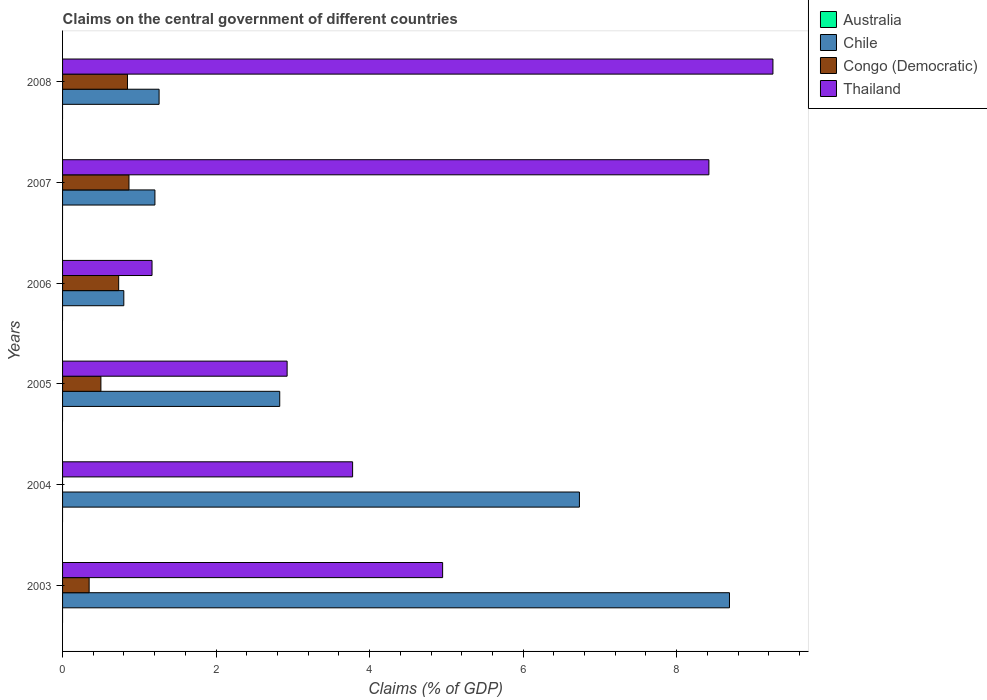How many different coloured bars are there?
Keep it short and to the point. 3. How many groups of bars are there?
Your answer should be compact. 6. Are the number of bars on each tick of the Y-axis equal?
Your answer should be compact. No. How many bars are there on the 2nd tick from the bottom?
Give a very brief answer. 2. What is the percentage of GDP claimed on the central government in Congo (Democratic) in 2005?
Ensure brevity in your answer.  0.5. Across all years, what is the maximum percentage of GDP claimed on the central government in Thailand?
Make the answer very short. 9.25. Across all years, what is the minimum percentage of GDP claimed on the central government in Australia?
Ensure brevity in your answer.  0. What is the total percentage of GDP claimed on the central government in Congo (Democratic) in the graph?
Your answer should be very brief. 3.29. What is the difference between the percentage of GDP claimed on the central government in Chile in 2006 and that in 2007?
Give a very brief answer. -0.41. What is the difference between the percentage of GDP claimed on the central government in Thailand in 2004 and the percentage of GDP claimed on the central government in Congo (Democratic) in 2007?
Your response must be concise. 2.91. What is the average percentage of GDP claimed on the central government in Congo (Democratic) per year?
Your answer should be compact. 0.55. In the year 2005, what is the difference between the percentage of GDP claimed on the central government in Chile and percentage of GDP claimed on the central government in Congo (Democratic)?
Make the answer very short. 2.33. In how many years, is the percentage of GDP claimed on the central government in Australia greater than 8 %?
Offer a very short reply. 0. What is the ratio of the percentage of GDP claimed on the central government in Thailand in 2004 to that in 2007?
Your answer should be compact. 0.45. Is the percentage of GDP claimed on the central government in Chile in 2006 less than that in 2008?
Your answer should be compact. Yes. Is the difference between the percentage of GDP claimed on the central government in Chile in 2005 and 2008 greater than the difference between the percentage of GDP claimed on the central government in Congo (Democratic) in 2005 and 2008?
Your answer should be compact. Yes. What is the difference between the highest and the second highest percentage of GDP claimed on the central government in Thailand?
Your answer should be very brief. 0.83. What is the difference between the highest and the lowest percentage of GDP claimed on the central government in Chile?
Offer a terse response. 7.89. In how many years, is the percentage of GDP claimed on the central government in Thailand greater than the average percentage of GDP claimed on the central government in Thailand taken over all years?
Provide a short and direct response. 2. Is the sum of the percentage of GDP claimed on the central government in Chile in 2005 and 2007 greater than the maximum percentage of GDP claimed on the central government in Congo (Democratic) across all years?
Keep it short and to the point. Yes. Are all the bars in the graph horizontal?
Make the answer very short. Yes. How many years are there in the graph?
Give a very brief answer. 6. What is the difference between two consecutive major ticks on the X-axis?
Provide a succinct answer. 2. Are the values on the major ticks of X-axis written in scientific E-notation?
Provide a short and direct response. No. Does the graph contain grids?
Offer a very short reply. No. Where does the legend appear in the graph?
Your answer should be very brief. Top right. What is the title of the graph?
Provide a short and direct response. Claims on the central government of different countries. Does "Turkey" appear as one of the legend labels in the graph?
Your response must be concise. No. What is the label or title of the X-axis?
Your answer should be very brief. Claims (% of GDP). What is the Claims (% of GDP) of Chile in 2003?
Your answer should be compact. 8.69. What is the Claims (% of GDP) of Congo (Democratic) in 2003?
Provide a succinct answer. 0.35. What is the Claims (% of GDP) in Thailand in 2003?
Give a very brief answer. 4.95. What is the Claims (% of GDP) of Australia in 2004?
Your answer should be compact. 0. What is the Claims (% of GDP) in Chile in 2004?
Offer a very short reply. 6.73. What is the Claims (% of GDP) of Thailand in 2004?
Your response must be concise. 3.78. What is the Claims (% of GDP) of Australia in 2005?
Provide a succinct answer. 0. What is the Claims (% of GDP) in Chile in 2005?
Make the answer very short. 2.83. What is the Claims (% of GDP) in Congo (Democratic) in 2005?
Provide a succinct answer. 0.5. What is the Claims (% of GDP) of Thailand in 2005?
Your response must be concise. 2.93. What is the Claims (% of GDP) of Chile in 2006?
Offer a terse response. 0.8. What is the Claims (% of GDP) in Congo (Democratic) in 2006?
Your answer should be compact. 0.73. What is the Claims (% of GDP) in Thailand in 2006?
Your answer should be compact. 1.17. What is the Claims (% of GDP) in Australia in 2007?
Provide a short and direct response. 0. What is the Claims (% of GDP) of Chile in 2007?
Ensure brevity in your answer.  1.2. What is the Claims (% of GDP) in Congo (Democratic) in 2007?
Make the answer very short. 0.87. What is the Claims (% of GDP) of Thailand in 2007?
Give a very brief answer. 8.42. What is the Claims (% of GDP) of Australia in 2008?
Your answer should be very brief. 0. What is the Claims (% of GDP) of Chile in 2008?
Your answer should be very brief. 1.26. What is the Claims (% of GDP) in Congo (Democratic) in 2008?
Ensure brevity in your answer.  0.85. What is the Claims (% of GDP) of Thailand in 2008?
Keep it short and to the point. 9.25. Across all years, what is the maximum Claims (% of GDP) of Chile?
Provide a succinct answer. 8.69. Across all years, what is the maximum Claims (% of GDP) in Congo (Democratic)?
Give a very brief answer. 0.87. Across all years, what is the maximum Claims (% of GDP) in Thailand?
Ensure brevity in your answer.  9.25. Across all years, what is the minimum Claims (% of GDP) in Chile?
Give a very brief answer. 0.8. Across all years, what is the minimum Claims (% of GDP) of Congo (Democratic)?
Offer a terse response. 0. Across all years, what is the minimum Claims (% of GDP) of Thailand?
Provide a short and direct response. 1.17. What is the total Claims (% of GDP) in Australia in the graph?
Ensure brevity in your answer.  0. What is the total Claims (% of GDP) in Chile in the graph?
Your response must be concise. 21.51. What is the total Claims (% of GDP) of Congo (Democratic) in the graph?
Keep it short and to the point. 3.29. What is the total Claims (% of GDP) of Thailand in the graph?
Provide a succinct answer. 30.49. What is the difference between the Claims (% of GDP) of Chile in 2003 and that in 2004?
Ensure brevity in your answer.  1.95. What is the difference between the Claims (% of GDP) of Thailand in 2003 and that in 2004?
Provide a short and direct response. 1.17. What is the difference between the Claims (% of GDP) in Chile in 2003 and that in 2005?
Your response must be concise. 5.86. What is the difference between the Claims (% of GDP) in Congo (Democratic) in 2003 and that in 2005?
Keep it short and to the point. -0.15. What is the difference between the Claims (% of GDP) in Thailand in 2003 and that in 2005?
Offer a very short reply. 2.03. What is the difference between the Claims (% of GDP) in Chile in 2003 and that in 2006?
Offer a terse response. 7.89. What is the difference between the Claims (% of GDP) in Congo (Democratic) in 2003 and that in 2006?
Ensure brevity in your answer.  -0.38. What is the difference between the Claims (% of GDP) in Thailand in 2003 and that in 2006?
Your answer should be very brief. 3.79. What is the difference between the Claims (% of GDP) of Chile in 2003 and that in 2007?
Provide a succinct answer. 7.48. What is the difference between the Claims (% of GDP) of Congo (Democratic) in 2003 and that in 2007?
Provide a succinct answer. -0.52. What is the difference between the Claims (% of GDP) in Thailand in 2003 and that in 2007?
Provide a succinct answer. -3.47. What is the difference between the Claims (% of GDP) of Chile in 2003 and that in 2008?
Offer a very short reply. 7.43. What is the difference between the Claims (% of GDP) of Congo (Democratic) in 2003 and that in 2008?
Make the answer very short. -0.5. What is the difference between the Claims (% of GDP) in Thailand in 2003 and that in 2008?
Your answer should be very brief. -4.3. What is the difference between the Claims (% of GDP) in Chile in 2004 and that in 2005?
Your answer should be very brief. 3.9. What is the difference between the Claims (% of GDP) of Thailand in 2004 and that in 2005?
Your answer should be very brief. 0.85. What is the difference between the Claims (% of GDP) of Chile in 2004 and that in 2006?
Your answer should be very brief. 5.94. What is the difference between the Claims (% of GDP) in Thailand in 2004 and that in 2006?
Offer a terse response. 2.61. What is the difference between the Claims (% of GDP) of Chile in 2004 and that in 2007?
Offer a terse response. 5.53. What is the difference between the Claims (% of GDP) of Thailand in 2004 and that in 2007?
Keep it short and to the point. -4.64. What is the difference between the Claims (% of GDP) of Chile in 2004 and that in 2008?
Offer a terse response. 5.48. What is the difference between the Claims (% of GDP) of Thailand in 2004 and that in 2008?
Provide a succinct answer. -5.48. What is the difference between the Claims (% of GDP) in Chile in 2005 and that in 2006?
Your answer should be compact. 2.03. What is the difference between the Claims (% of GDP) of Congo (Democratic) in 2005 and that in 2006?
Provide a succinct answer. -0.23. What is the difference between the Claims (% of GDP) of Thailand in 2005 and that in 2006?
Your answer should be compact. 1.76. What is the difference between the Claims (% of GDP) of Chile in 2005 and that in 2007?
Give a very brief answer. 1.63. What is the difference between the Claims (% of GDP) in Congo (Democratic) in 2005 and that in 2007?
Your response must be concise. -0.37. What is the difference between the Claims (% of GDP) in Thailand in 2005 and that in 2007?
Your answer should be compact. -5.49. What is the difference between the Claims (% of GDP) of Chile in 2005 and that in 2008?
Offer a very short reply. 1.57. What is the difference between the Claims (% of GDP) of Congo (Democratic) in 2005 and that in 2008?
Your response must be concise. -0.35. What is the difference between the Claims (% of GDP) of Thailand in 2005 and that in 2008?
Offer a terse response. -6.33. What is the difference between the Claims (% of GDP) of Chile in 2006 and that in 2007?
Offer a very short reply. -0.41. What is the difference between the Claims (% of GDP) in Congo (Democratic) in 2006 and that in 2007?
Offer a very short reply. -0.13. What is the difference between the Claims (% of GDP) of Thailand in 2006 and that in 2007?
Make the answer very short. -7.25. What is the difference between the Claims (% of GDP) of Chile in 2006 and that in 2008?
Give a very brief answer. -0.46. What is the difference between the Claims (% of GDP) in Congo (Democratic) in 2006 and that in 2008?
Offer a very short reply. -0.11. What is the difference between the Claims (% of GDP) in Thailand in 2006 and that in 2008?
Your answer should be compact. -8.09. What is the difference between the Claims (% of GDP) of Chile in 2007 and that in 2008?
Keep it short and to the point. -0.05. What is the difference between the Claims (% of GDP) of Congo (Democratic) in 2007 and that in 2008?
Provide a short and direct response. 0.02. What is the difference between the Claims (% of GDP) in Thailand in 2007 and that in 2008?
Offer a very short reply. -0.83. What is the difference between the Claims (% of GDP) in Chile in 2003 and the Claims (% of GDP) in Thailand in 2004?
Your answer should be very brief. 4.91. What is the difference between the Claims (% of GDP) of Congo (Democratic) in 2003 and the Claims (% of GDP) of Thailand in 2004?
Provide a short and direct response. -3.43. What is the difference between the Claims (% of GDP) in Chile in 2003 and the Claims (% of GDP) in Congo (Democratic) in 2005?
Keep it short and to the point. 8.19. What is the difference between the Claims (% of GDP) in Chile in 2003 and the Claims (% of GDP) in Thailand in 2005?
Offer a very short reply. 5.76. What is the difference between the Claims (% of GDP) of Congo (Democratic) in 2003 and the Claims (% of GDP) of Thailand in 2005?
Your answer should be very brief. -2.58. What is the difference between the Claims (% of GDP) in Chile in 2003 and the Claims (% of GDP) in Congo (Democratic) in 2006?
Provide a short and direct response. 7.96. What is the difference between the Claims (% of GDP) in Chile in 2003 and the Claims (% of GDP) in Thailand in 2006?
Ensure brevity in your answer.  7.52. What is the difference between the Claims (% of GDP) of Congo (Democratic) in 2003 and the Claims (% of GDP) of Thailand in 2006?
Offer a very short reply. -0.82. What is the difference between the Claims (% of GDP) in Chile in 2003 and the Claims (% of GDP) in Congo (Democratic) in 2007?
Provide a short and direct response. 7.82. What is the difference between the Claims (% of GDP) in Chile in 2003 and the Claims (% of GDP) in Thailand in 2007?
Offer a very short reply. 0.27. What is the difference between the Claims (% of GDP) in Congo (Democratic) in 2003 and the Claims (% of GDP) in Thailand in 2007?
Make the answer very short. -8.07. What is the difference between the Claims (% of GDP) of Chile in 2003 and the Claims (% of GDP) of Congo (Democratic) in 2008?
Your answer should be very brief. 7.84. What is the difference between the Claims (% of GDP) of Chile in 2003 and the Claims (% of GDP) of Thailand in 2008?
Your answer should be very brief. -0.57. What is the difference between the Claims (% of GDP) of Congo (Democratic) in 2003 and the Claims (% of GDP) of Thailand in 2008?
Ensure brevity in your answer.  -8.91. What is the difference between the Claims (% of GDP) of Chile in 2004 and the Claims (% of GDP) of Congo (Democratic) in 2005?
Offer a terse response. 6.23. What is the difference between the Claims (% of GDP) of Chile in 2004 and the Claims (% of GDP) of Thailand in 2005?
Give a very brief answer. 3.81. What is the difference between the Claims (% of GDP) in Chile in 2004 and the Claims (% of GDP) in Congo (Democratic) in 2006?
Give a very brief answer. 6. What is the difference between the Claims (% of GDP) in Chile in 2004 and the Claims (% of GDP) in Thailand in 2006?
Provide a short and direct response. 5.57. What is the difference between the Claims (% of GDP) in Chile in 2004 and the Claims (% of GDP) in Congo (Democratic) in 2007?
Your response must be concise. 5.87. What is the difference between the Claims (% of GDP) of Chile in 2004 and the Claims (% of GDP) of Thailand in 2007?
Ensure brevity in your answer.  -1.69. What is the difference between the Claims (% of GDP) in Chile in 2004 and the Claims (% of GDP) in Congo (Democratic) in 2008?
Your answer should be compact. 5.89. What is the difference between the Claims (% of GDP) of Chile in 2004 and the Claims (% of GDP) of Thailand in 2008?
Make the answer very short. -2.52. What is the difference between the Claims (% of GDP) in Chile in 2005 and the Claims (% of GDP) in Congo (Democratic) in 2006?
Give a very brief answer. 2.1. What is the difference between the Claims (% of GDP) of Chile in 2005 and the Claims (% of GDP) of Thailand in 2006?
Provide a succinct answer. 1.66. What is the difference between the Claims (% of GDP) in Congo (Democratic) in 2005 and the Claims (% of GDP) in Thailand in 2006?
Offer a terse response. -0.67. What is the difference between the Claims (% of GDP) of Chile in 2005 and the Claims (% of GDP) of Congo (Democratic) in 2007?
Provide a succinct answer. 1.96. What is the difference between the Claims (% of GDP) in Chile in 2005 and the Claims (% of GDP) in Thailand in 2007?
Your answer should be compact. -5.59. What is the difference between the Claims (% of GDP) of Congo (Democratic) in 2005 and the Claims (% of GDP) of Thailand in 2007?
Provide a succinct answer. -7.92. What is the difference between the Claims (% of GDP) of Chile in 2005 and the Claims (% of GDP) of Congo (Democratic) in 2008?
Give a very brief answer. 1.98. What is the difference between the Claims (% of GDP) in Chile in 2005 and the Claims (% of GDP) in Thailand in 2008?
Keep it short and to the point. -6.43. What is the difference between the Claims (% of GDP) of Congo (Democratic) in 2005 and the Claims (% of GDP) of Thailand in 2008?
Make the answer very short. -8.75. What is the difference between the Claims (% of GDP) in Chile in 2006 and the Claims (% of GDP) in Congo (Democratic) in 2007?
Offer a terse response. -0.07. What is the difference between the Claims (% of GDP) in Chile in 2006 and the Claims (% of GDP) in Thailand in 2007?
Make the answer very short. -7.62. What is the difference between the Claims (% of GDP) in Congo (Democratic) in 2006 and the Claims (% of GDP) in Thailand in 2007?
Make the answer very short. -7.69. What is the difference between the Claims (% of GDP) of Chile in 2006 and the Claims (% of GDP) of Congo (Democratic) in 2008?
Ensure brevity in your answer.  -0.05. What is the difference between the Claims (% of GDP) of Chile in 2006 and the Claims (% of GDP) of Thailand in 2008?
Your response must be concise. -8.46. What is the difference between the Claims (% of GDP) in Congo (Democratic) in 2006 and the Claims (% of GDP) in Thailand in 2008?
Offer a terse response. -8.52. What is the difference between the Claims (% of GDP) of Chile in 2007 and the Claims (% of GDP) of Congo (Democratic) in 2008?
Provide a short and direct response. 0.36. What is the difference between the Claims (% of GDP) in Chile in 2007 and the Claims (% of GDP) in Thailand in 2008?
Provide a succinct answer. -8.05. What is the difference between the Claims (% of GDP) of Congo (Democratic) in 2007 and the Claims (% of GDP) of Thailand in 2008?
Your answer should be compact. -8.39. What is the average Claims (% of GDP) of Australia per year?
Provide a succinct answer. 0. What is the average Claims (% of GDP) of Chile per year?
Provide a succinct answer. 3.58. What is the average Claims (% of GDP) of Congo (Democratic) per year?
Make the answer very short. 0.55. What is the average Claims (% of GDP) of Thailand per year?
Offer a terse response. 5.08. In the year 2003, what is the difference between the Claims (% of GDP) in Chile and Claims (% of GDP) in Congo (Democratic)?
Offer a very short reply. 8.34. In the year 2003, what is the difference between the Claims (% of GDP) in Chile and Claims (% of GDP) in Thailand?
Your answer should be very brief. 3.74. In the year 2003, what is the difference between the Claims (% of GDP) of Congo (Democratic) and Claims (% of GDP) of Thailand?
Offer a very short reply. -4.6. In the year 2004, what is the difference between the Claims (% of GDP) in Chile and Claims (% of GDP) in Thailand?
Offer a very short reply. 2.95. In the year 2005, what is the difference between the Claims (% of GDP) in Chile and Claims (% of GDP) in Congo (Democratic)?
Provide a short and direct response. 2.33. In the year 2005, what is the difference between the Claims (% of GDP) of Chile and Claims (% of GDP) of Thailand?
Offer a very short reply. -0.1. In the year 2005, what is the difference between the Claims (% of GDP) of Congo (Democratic) and Claims (% of GDP) of Thailand?
Your answer should be very brief. -2.43. In the year 2006, what is the difference between the Claims (% of GDP) in Chile and Claims (% of GDP) in Congo (Democratic)?
Make the answer very short. 0.07. In the year 2006, what is the difference between the Claims (% of GDP) of Chile and Claims (% of GDP) of Thailand?
Give a very brief answer. -0.37. In the year 2006, what is the difference between the Claims (% of GDP) in Congo (Democratic) and Claims (% of GDP) in Thailand?
Your answer should be very brief. -0.43. In the year 2007, what is the difference between the Claims (% of GDP) in Chile and Claims (% of GDP) in Congo (Democratic)?
Give a very brief answer. 0.34. In the year 2007, what is the difference between the Claims (% of GDP) of Chile and Claims (% of GDP) of Thailand?
Offer a very short reply. -7.22. In the year 2007, what is the difference between the Claims (% of GDP) in Congo (Democratic) and Claims (% of GDP) in Thailand?
Your answer should be compact. -7.55. In the year 2008, what is the difference between the Claims (% of GDP) of Chile and Claims (% of GDP) of Congo (Democratic)?
Your answer should be compact. 0.41. In the year 2008, what is the difference between the Claims (% of GDP) of Chile and Claims (% of GDP) of Thailand?
Your answer should be compact. -8. In the year 2008, what is the difference between the Claims (% of GDP) of Congo (Democratic) and Claims (% of GDP) of Thailand?
Offer a very short reply. -8.41. What is the ratio of the Claims (% of GDP) of Chile in 2003 to that in 2004?
Keep it short and to the point. 1.29. What is the ratio of the Claims (% of GDP) of Thailand in 2003 to that in 2004?
Provide a short and direct response. 1.31. What is the ratio of the Claims (% of GDP) of Chile in 2003 to that in 2005?
Give a very brief answer. 3.07. What is the ratio of the Claims (% of GDP) in Congo (Democratic) in 2003 to that in 2005?
Provide a short and direct response. 0.69. What is the ratio of the Claims (% of GDP) in Thailand in 2003 to that in 2005?
Provide a short and direct response. 1.69. What is the ratio of the Claims (% of GDP) of Chile in 2003 to that in 2006?
Offer a terse response. 10.89. What is the ratio of the Claims (% of GDP) of Congo (Democratic) in 2003 to that in 2006?
Your answer should be compact. 0.47. What is the ratio of the Claims (% of GDP) in Thailand in 2003 to that in 2006?
Provide a short and direct response. 4.25. What is the ratio of the Claims (% of GDP) in Chile in 2003 to that in 2007?
Provide a succinct answer. 7.22. What is the ratio of the Claims (% of GDP) in Congo (Democratic) in 2003 to that in 2007?
Ensure brevity in your answer.  0.4. What is the ratio of the Claims (% of GDP) in Thailand in 2003 to that in 2007?
Give a very brief answer. 0.59. What is the ratio of the Claims (% of GDP) in Chile in 2003 to that in 2008?
Provide a succinct answer. 6.91. What is the ratio of the Claims (% of GDP) of Congo (Democratic) in 2003 to that in 2008?
Offer a terse response. 0.41. What is the ratio of the Claims (% of GDP) of Thailand in 2003 to that in 2008?
Give a very brief answer. 0.54. What is the ratio of the Claims (% of GDP) of Chile in 2004 to that in 2005?
Your answer should be very brief. 2.38. What is the ratio of the Claims (% of GDP) of Thailand in 2004 to that in 2005?
Keep it short and to the point. 1.29. What is the ratio of the Claims (% of GDP) in Chile in 2004 to that in 2006?
Ensure brevity in your answer.  8.44. What is the ratio of the Claims (% of GDP) of Thailand in 2004 to that in 2006?
Make the answer very short. 3.24. What is the ratio of the Claims (% of GDP) of Chile in 2004 to that in 2007?
Give a very brief answer. 5.6. What is the ratio of the Claims (% of GDP) of Thailand in 2004 to that in 2007?
Provide a succinct answer. 0.45. What is the ratio of the Claims (% of GDP) in Chile in 2004 to that in 2008?
Provide a succinct answer. 5.35. What is the ratio of the Claims (% of GDP) of Thailand in 2004 to that in 2008?
Offer a terse response. 0.41. What is the ratio of the Claims (% of GDP) of Chile in 2005 to that in 2006?
Keep it short and to the point. 3.55. What is the ratio of the Claims (% of GDP) of Congo (Democratic) in 2005 to that in 2006?
Offer a terse response. 0.68. What is the ratio of the Claims (% of GDP) in Thailand in 2005 to that in 2006?
Give a very brief answer. 2.51. What is the ratio of the Claims (% of GDP) of Chile in 2005 to that in 2007?
Your answer should be very brief. 2.35. What is the ratio of the Claims (% of GDP) of Congo (Democratic) in 2005 to that in 2007?
Provide a succinct answer. 0.58. What is the ratio of the Claims (% of GDP) in Thailand in 2005 to that in 2007?
Your answer should be compact. 0.35. What is the ratio of the Claims (% of GDP) of Chile in 2005 to that in 2008?
Offer a terse response. 2.25. What is the ratio of the Claims (% of GDP) of Congo (Democratic) in 2005 to that in 2008?
Make the answer very short. 0.59. What is the ratio of the Claims (% of GDP) in Thailand in 2005 to that in 2008?
Give a very brief answer. 0.32. What is the ratio of the Claims (% of GDP) of Chile in 2006 to that in 2007?
Keep it short and to the point. 0.66. What is the ratio of the Claims (% of GDP) of Congo (Democratic) in 2006 to that in 2007?
Ensure brevity in your answer.  0.84. What is the ratio of the Claims (% of GDP) of Thailand in 2006 to that in 2007?
Provide a short and direct response. 0.14. What is the ratio of the Claims (% of GDP) in Chile in 2006 to that in 2008?
Your answer should be very brief. 0.63. What is the ratio of the Claims (% of GDP) of Congo (Democratic) in 2006 to that in 2008?
Offer a very short reply. 0.86. What is the ratio of the Claims (% of GDP) of Thailand in 2006 to that in 2008?
Offer a terse response. 0.13. What is the ratio of the Claims (% of GDP) in Chile in 2007 to that in 2008?
Make the answer very short. 0.96. What is the ratio of the Claims (% of GDP) in Congo (Democratic) in 2007 to that in 2008?
Your answer should be very brief. 1.02. What is the ratio of the Claims (% of GDP) in Thailand in 2007 to that in 2008?
Provide a short and direct response. 0.91. What is the difference between the highest and the second highest Claims (% of GDP) of Chile?
Your answer should be very brief. 1.95. What is the difference between the highest and the second highest Claims (% of GDP) of Congo (Democratic)?
Ensure brevity in your answer.  0.02. What is the difference between the highest and the second highest Claims (% of GDP) in Thailand?
Your answer should be compact. 0.83. What is the difference between the highest and the lowest Claims (% of GDP) in Chile?
Ensure brevity in your answer.  7.89. What is the difference between the highest and the lowest Claims (% of GDP) in Congo (Democratic)?
Make the answer very short. 0.87. What is the difference between the highest and the lowest Claims (% of GDP) in Thailand?
Provide a succinct answer. 8.09. 